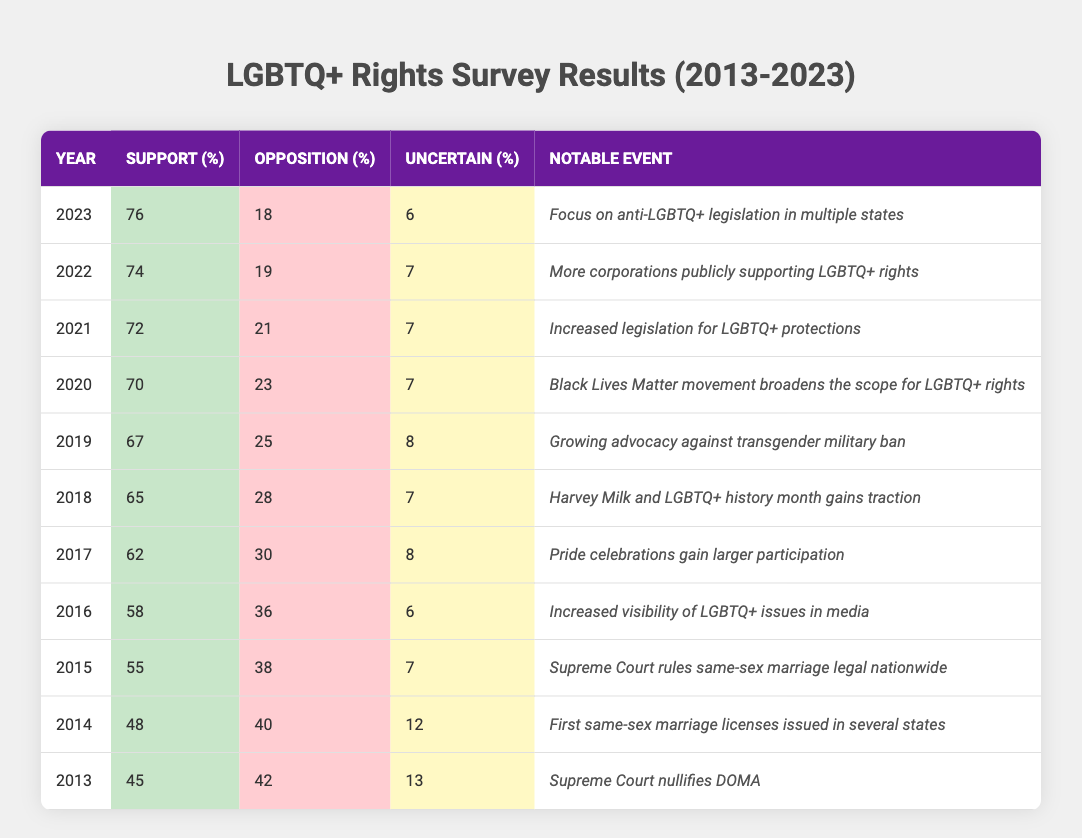What was the percentage of support for LGBTQ+ rights in 2015? According to the data for 2015, the percentage of support for LGBTQ+ rights was listed as 55%.
Answer: 55% Which year had the highest percentage of opposition to LGBTQ+ rights? By examining the table, the highest percentage of opposition occurred in 2013, with 42%.
Answer: 42% What notable event occurred in 2020? The table states that in 2020, the notable event was the Black Lives Matter movement broadening the scope for LGBTQ+ rights.
Answer: Black Lives Matter movement broadens the scope for LGBTQ+ rights What is the average percentage of support for LGBTQ+ rights from 2013 to 2023? Adding the percentages of support from each year (45 + 48 + 55 + 58 + 62 + 65 + 67 + 70 + 72 + 74 + 76 =  792) and dividing by the number of years (11) gives an average of approximately 72%.
Answer: 72% Did the percentage of those uncertain about LGBTQ+ rights increase or decrease from 2013 to 2023? In 2013, the percentage uncertain was 13%, and in 2023 it decreased to 6%. Therefore, the percentage of those uncertain decreased over the ten years.
Answer: Decreased Identify the year with the largest increase in support compared to the previous year. From the table, 2015 shows an increase from 55% in 2014 (48% to 55%) and 2020 shows a significant increase from 70% in 2019 (67% to 70%). However, the largest increase was between 2013 and 2015, 10%.
Answer: 2015 Was there any year where the percentage of support reached 70% or higher? Analyzing the table, the percentage of support reached 70% in 2020 for the first time.
Answer: Yes What was the percentage of uncertainty in 2016 and how does it compare with the percentage of opposition in the same year? In 2016, the percentage of uncertainty was 6%, while the percentage of opposition was 36%. Clearly, opposition was much higher than uncertainty that year.
Answer: 6%, higher opposition How many consecutive years did support for LGBTQ+ rights increase from 2015 to 2020? From 2015 to 2020, support increased every year, marking 5 consecutive years of growth (2016, 2017, 2018, 2019, and 2020).
Answer: 5 years What trend can be observed regarding the percentages of opposition from 2013 to 2023? The table indicates a clear downward trend in opposition percentages, starting from 42% in 2013 down to 18% in 2023.
Answer: Downward trend In which year did the percentage of support increase the most compared to the previous year? By examining the yearly increases, the most significant jump occurred between 2019 (67%) and 2020 (70%), a 3% increase.
Answer: 3% increase between 2019 and 2020 